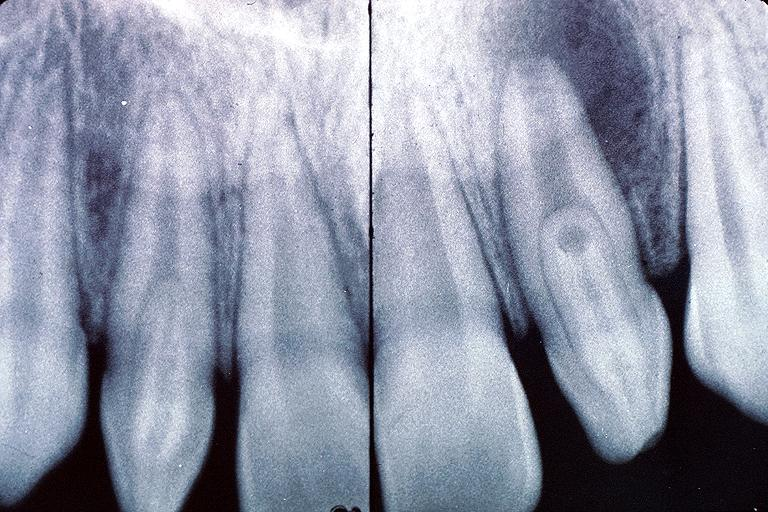where is this?
Answer the question using a single word or phrase. Oral 